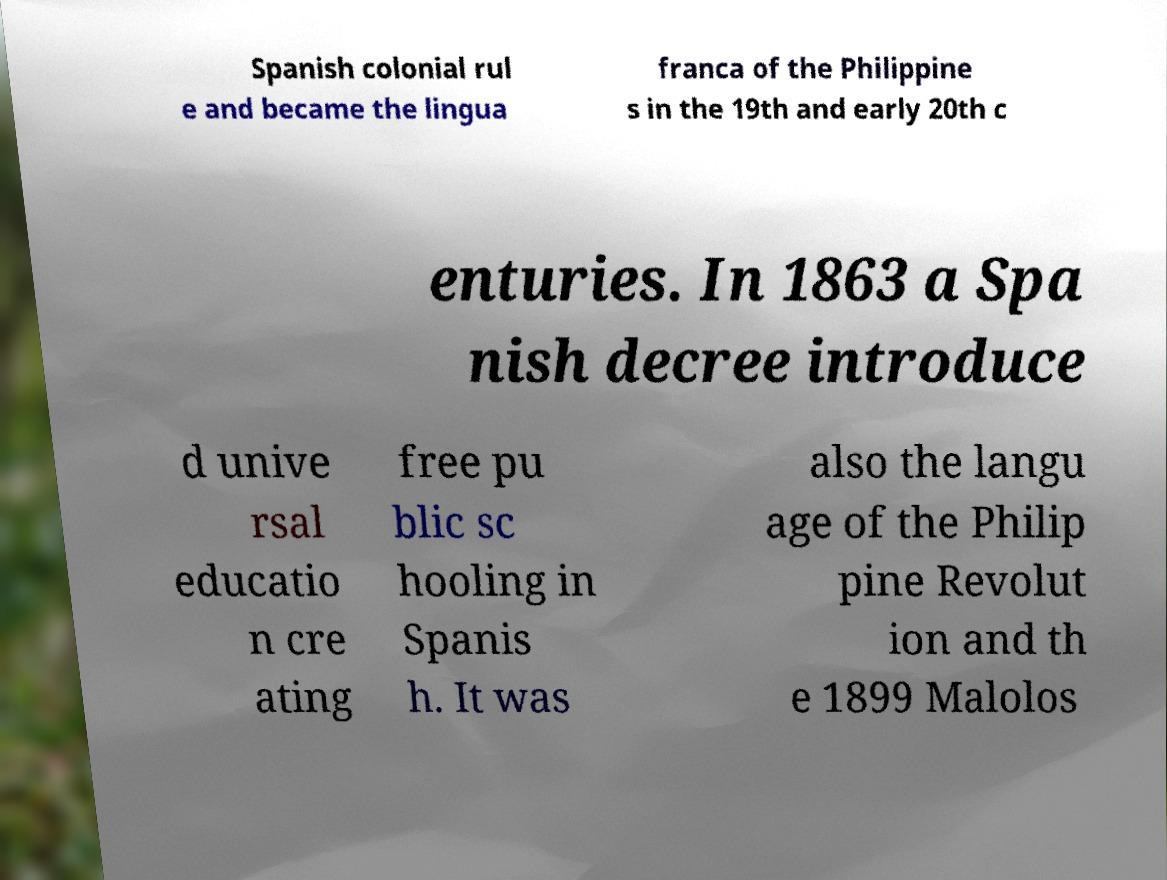For documentation purposes, I need the text within this image transcribed. Could you provide that? Spanish colonial rul e and became the lingua franca of the Philippine s in the 19th and early 20th c enturies. In 1863 a Spa nish decree introduce d unive rsal educatio n cre ating free pu blic sc hooling in Spanis h. It was also the langu age of the Philip pine Revolut ion and th e 1899 Malolos 